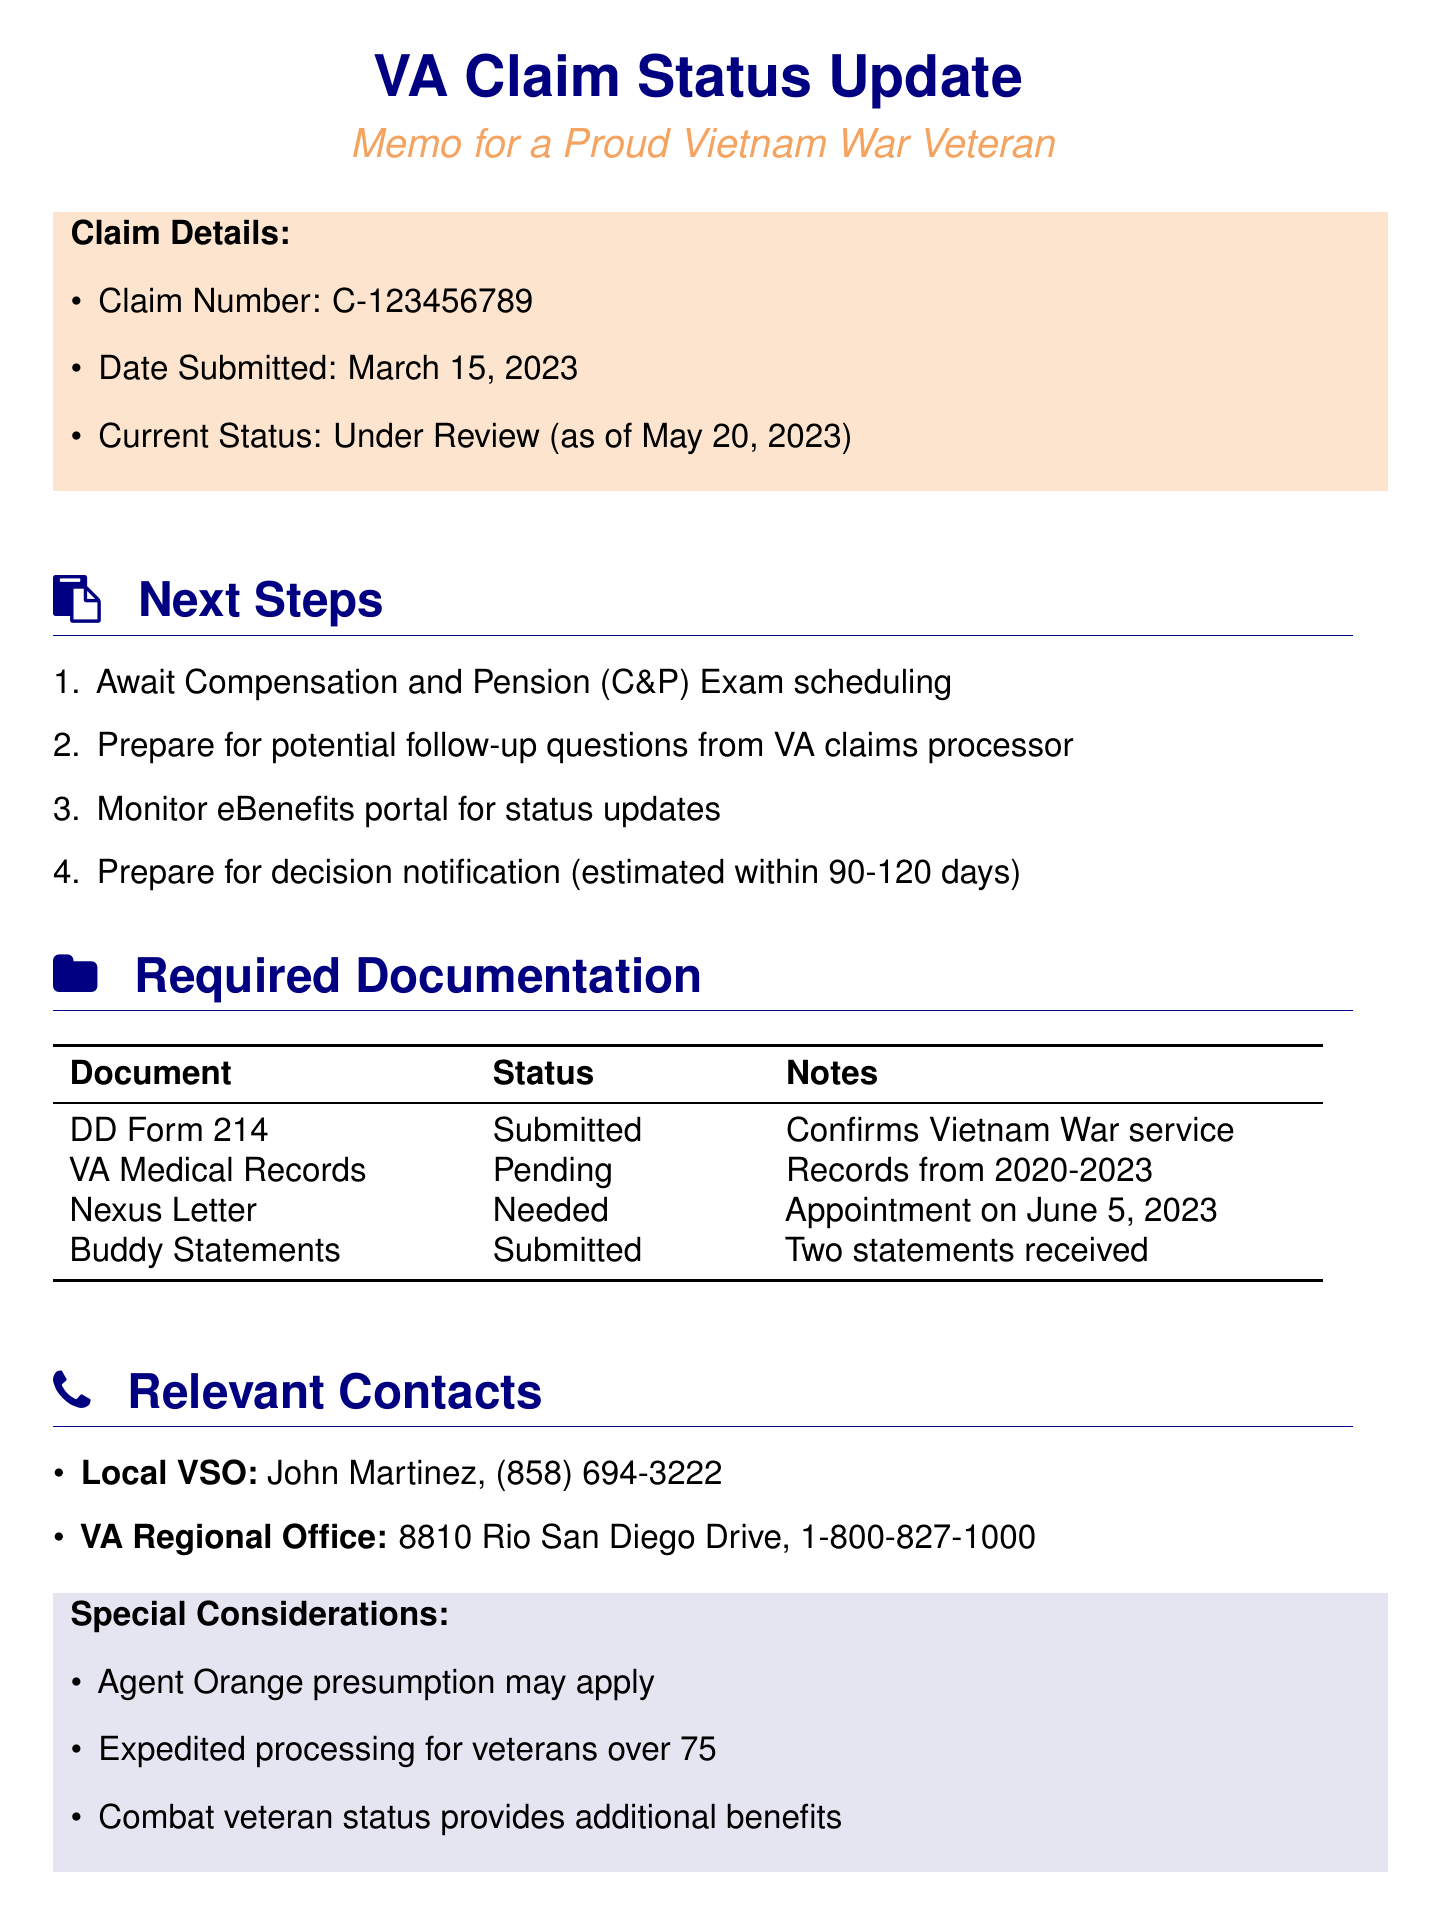What is the claim number? The claim number is mentioned under Claim Details in the document.
Answer: C-123456789 When was the claim submitted? The submission date is given in the Claim Details section of the document.
Answer: March 15, 2023 What is the current status of the claim? The current status is provided in the Claim Details section of the document.
Answer: Under Review Who is the local VSO contact? The local VSO contact name and organization are listed in the Relevant Contacts section.
Answer: John Martinez, San Diego County Veterans Service Office What is the status of the Nexus letter? The status of the Nexus letter is mentioned in the Required Documentation table.
Answer: Needed Which document is pending? The Required Documentation table lists the documents and their statuses.
Answer: Medical records from VA San Diego Healthcare System What is estimated for decision notification? The estimated time frame for decision notification can be found in the Next Steps section.
Answer: Within 90-120 days What special consideration applies to veterans over 75? The special considerations section outlines specific benefits related to age.
Answer: Expedited processing What is the meeting schedule for the Vietnam Veterans of America - San Diego Chapter 472? The meeting schedule is provided in the Additional Resources section.
Answer: Every 3rd Saturday at 10:00 AM 